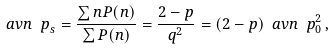Convert formula to latex. <formula><loc_0><loc_0><loc_500><loc_500>\ a v { n _ { \ } p } _ { s } = \frac { \sum n P ( n ) } { \sum P ( n ) } = \frac { 2 - p } { q ^ { 2 } } = ( 2 - p ) \ a v { n _ { \ } p } _ { 0 } ^ { 2 } \, ,</formula> 